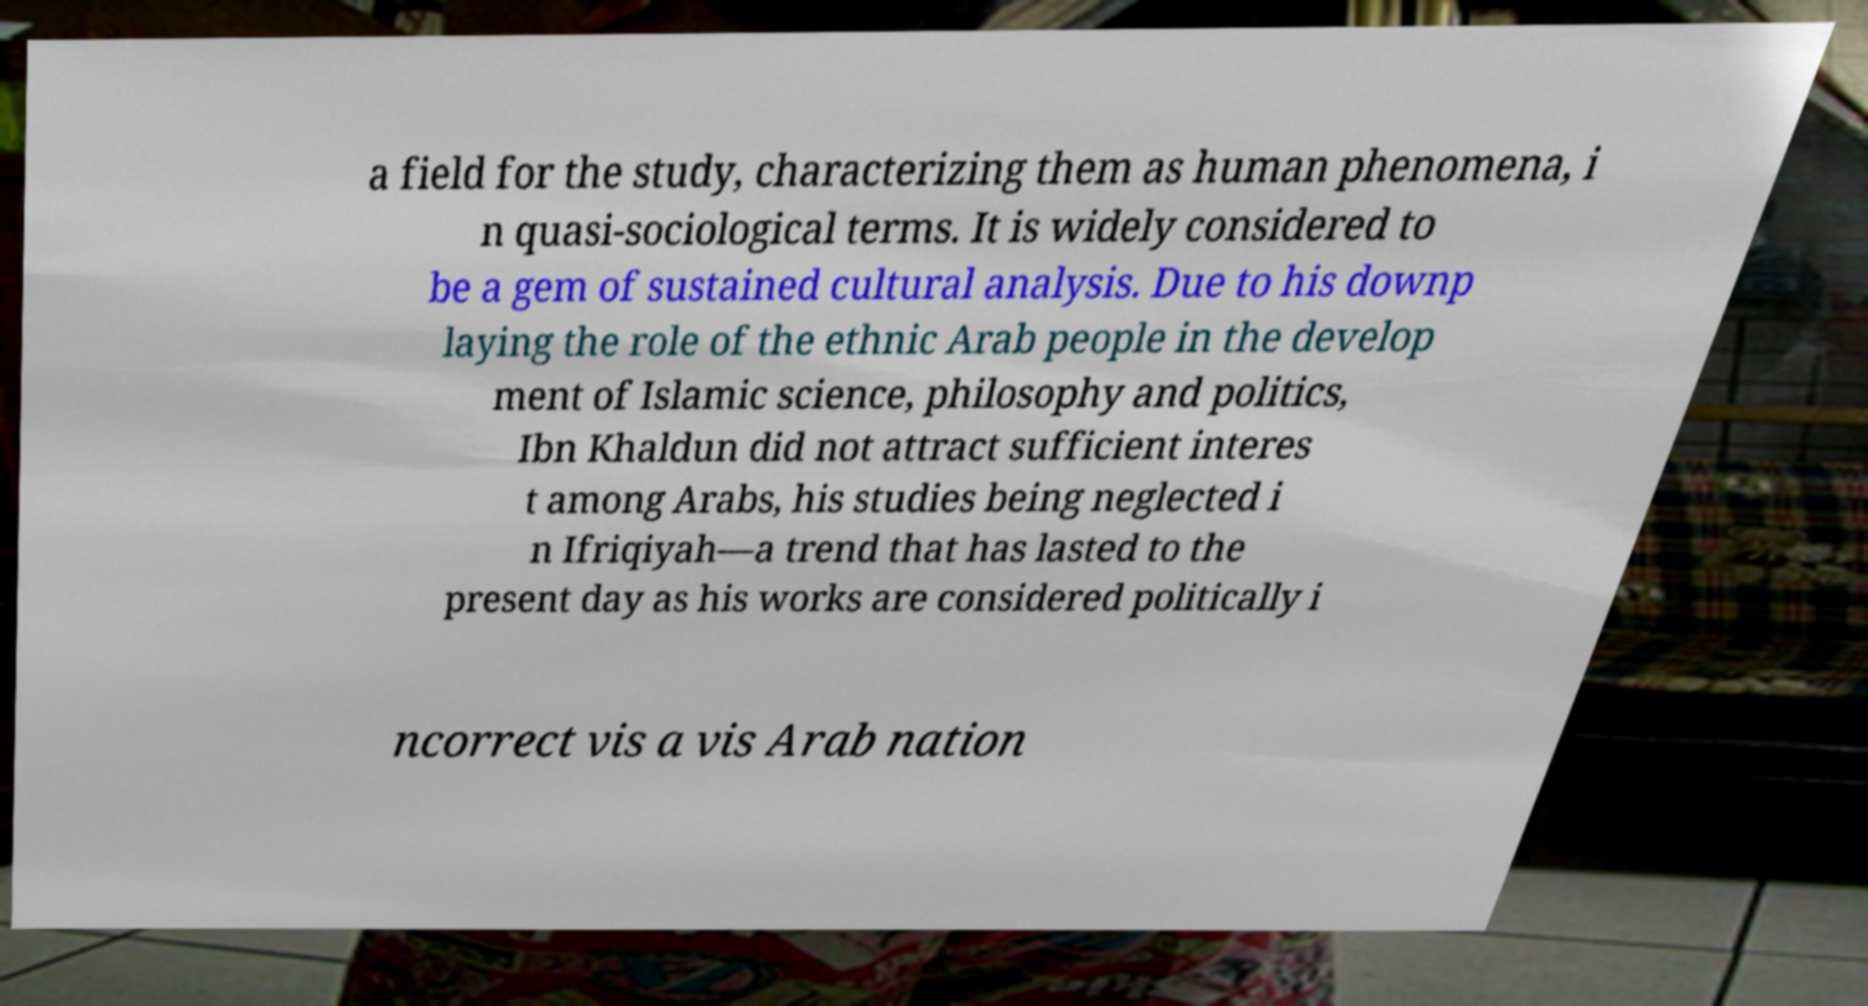I need the written content from this picture converted into text. Can you do that? a field for the study, characterizing them as human phenomena, i n quasi-sociological terms. It is widely considered to be a gem of sustained cultural analysis. Due to his downp laying the role of the ethnic Arab people in the develop ment of Islamic science, philosophy and politics, Ibn Khaldun did not attract sufficient interes t among Arabs, his studies being neglected i n Ifriqiyah—a trend that has lasted to the present day as his works are considered politically i ncorrect vis a vis Arab nation 